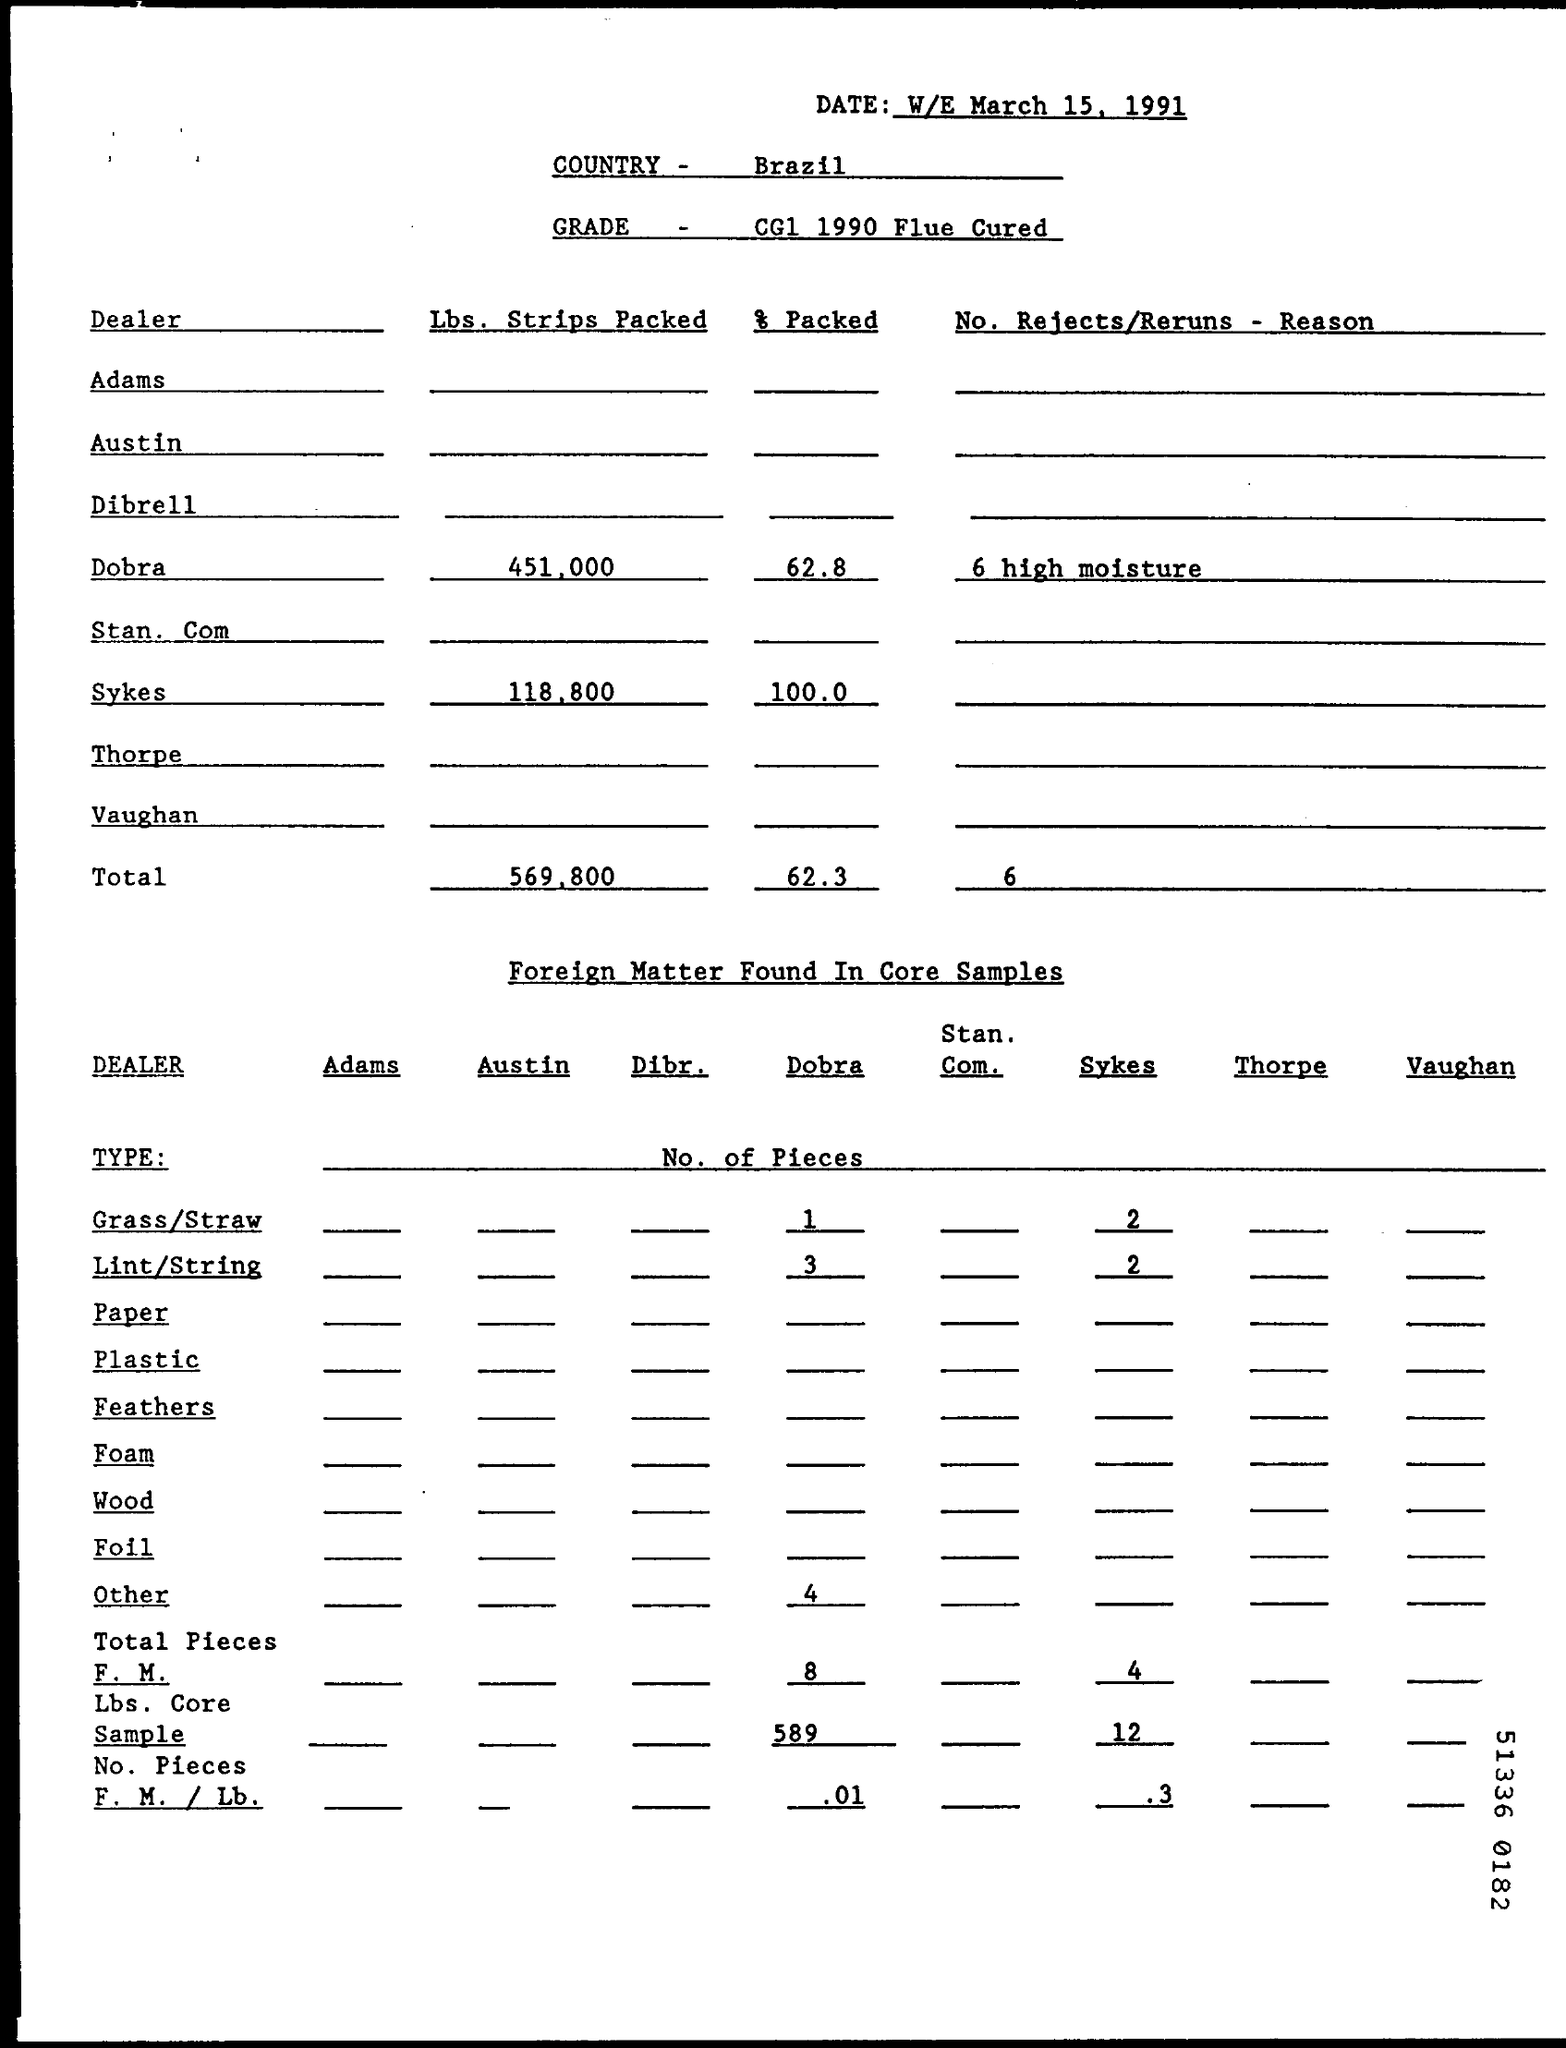Can you tell me the amount of foreign matter found in the core samples? The amount of foreign matter consisting of grass/straw, lint/string, and other unspecified materials found in the core samples is listed as totaling 8 pieces. The breakdown is 1 piece of grass/straw, 5 pieces of lint/string, and 2 other pieces, resulting in 0.01 foreign matters per pound.  What does the 'No. Rejects/Returns’ data indicate? The 'No. Rejects/Returns' section indicates that there were a total of 6 rejections or returns, all attributed to high moisture content according to the report. This data seems particularly associated with Dobra, which is the only dealer with an annotated reason for returns. 